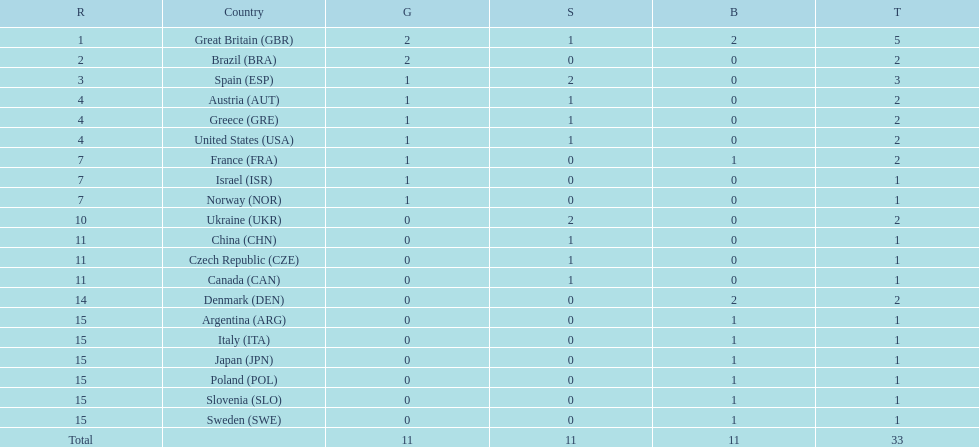How many countries won at least 1 gold and 1 silver medal? 5. 